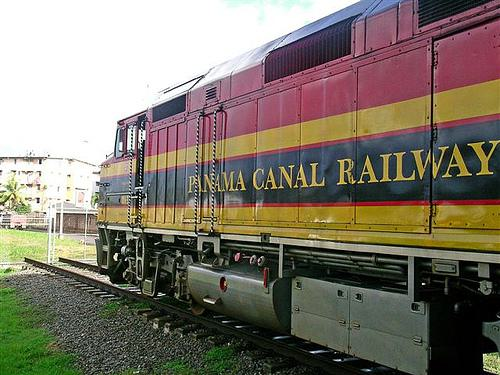How might the weather conditions affect railway operations? The image shows a day with partial cloud cover, suggesting variable weather. Such conditions could affect visibility for the train operators and potentially influence the train's traction on the tracks. Additionally, weather is a crucial factor for scheduling and safety in railway operations, especially in a region like Panama where heavy rains can occur. 